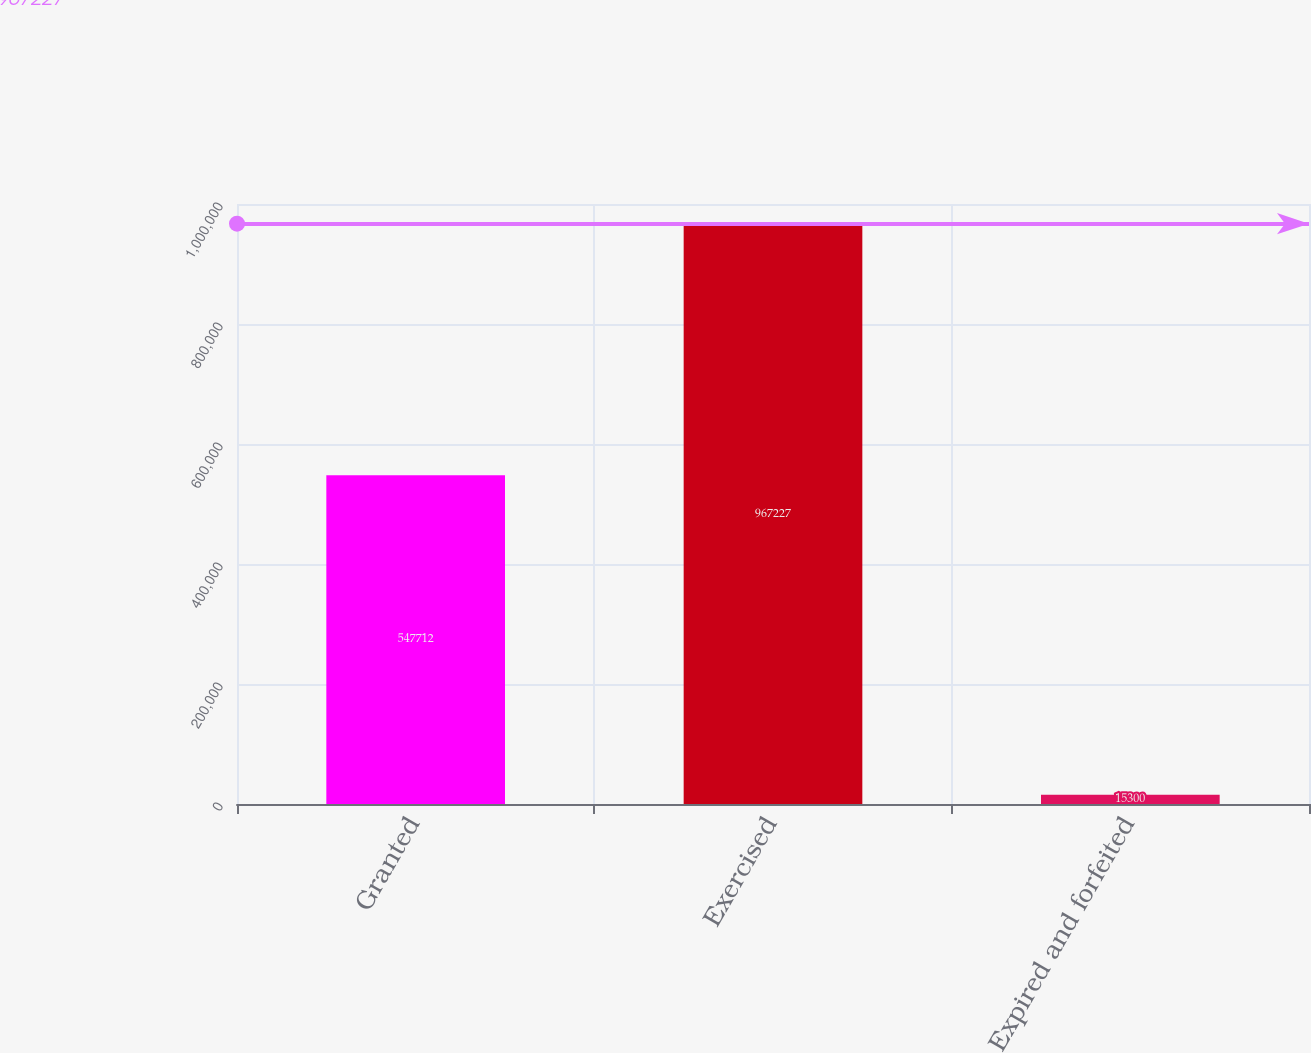<chart> <loc_0><loc_0><loc_500><loc_500><bar_chart><fcel>Granted<fcel>Exercised<fcel>Expired and forfeited<nl><fcel>547712<fcel>967227<fcel>15300<nl></chart> 